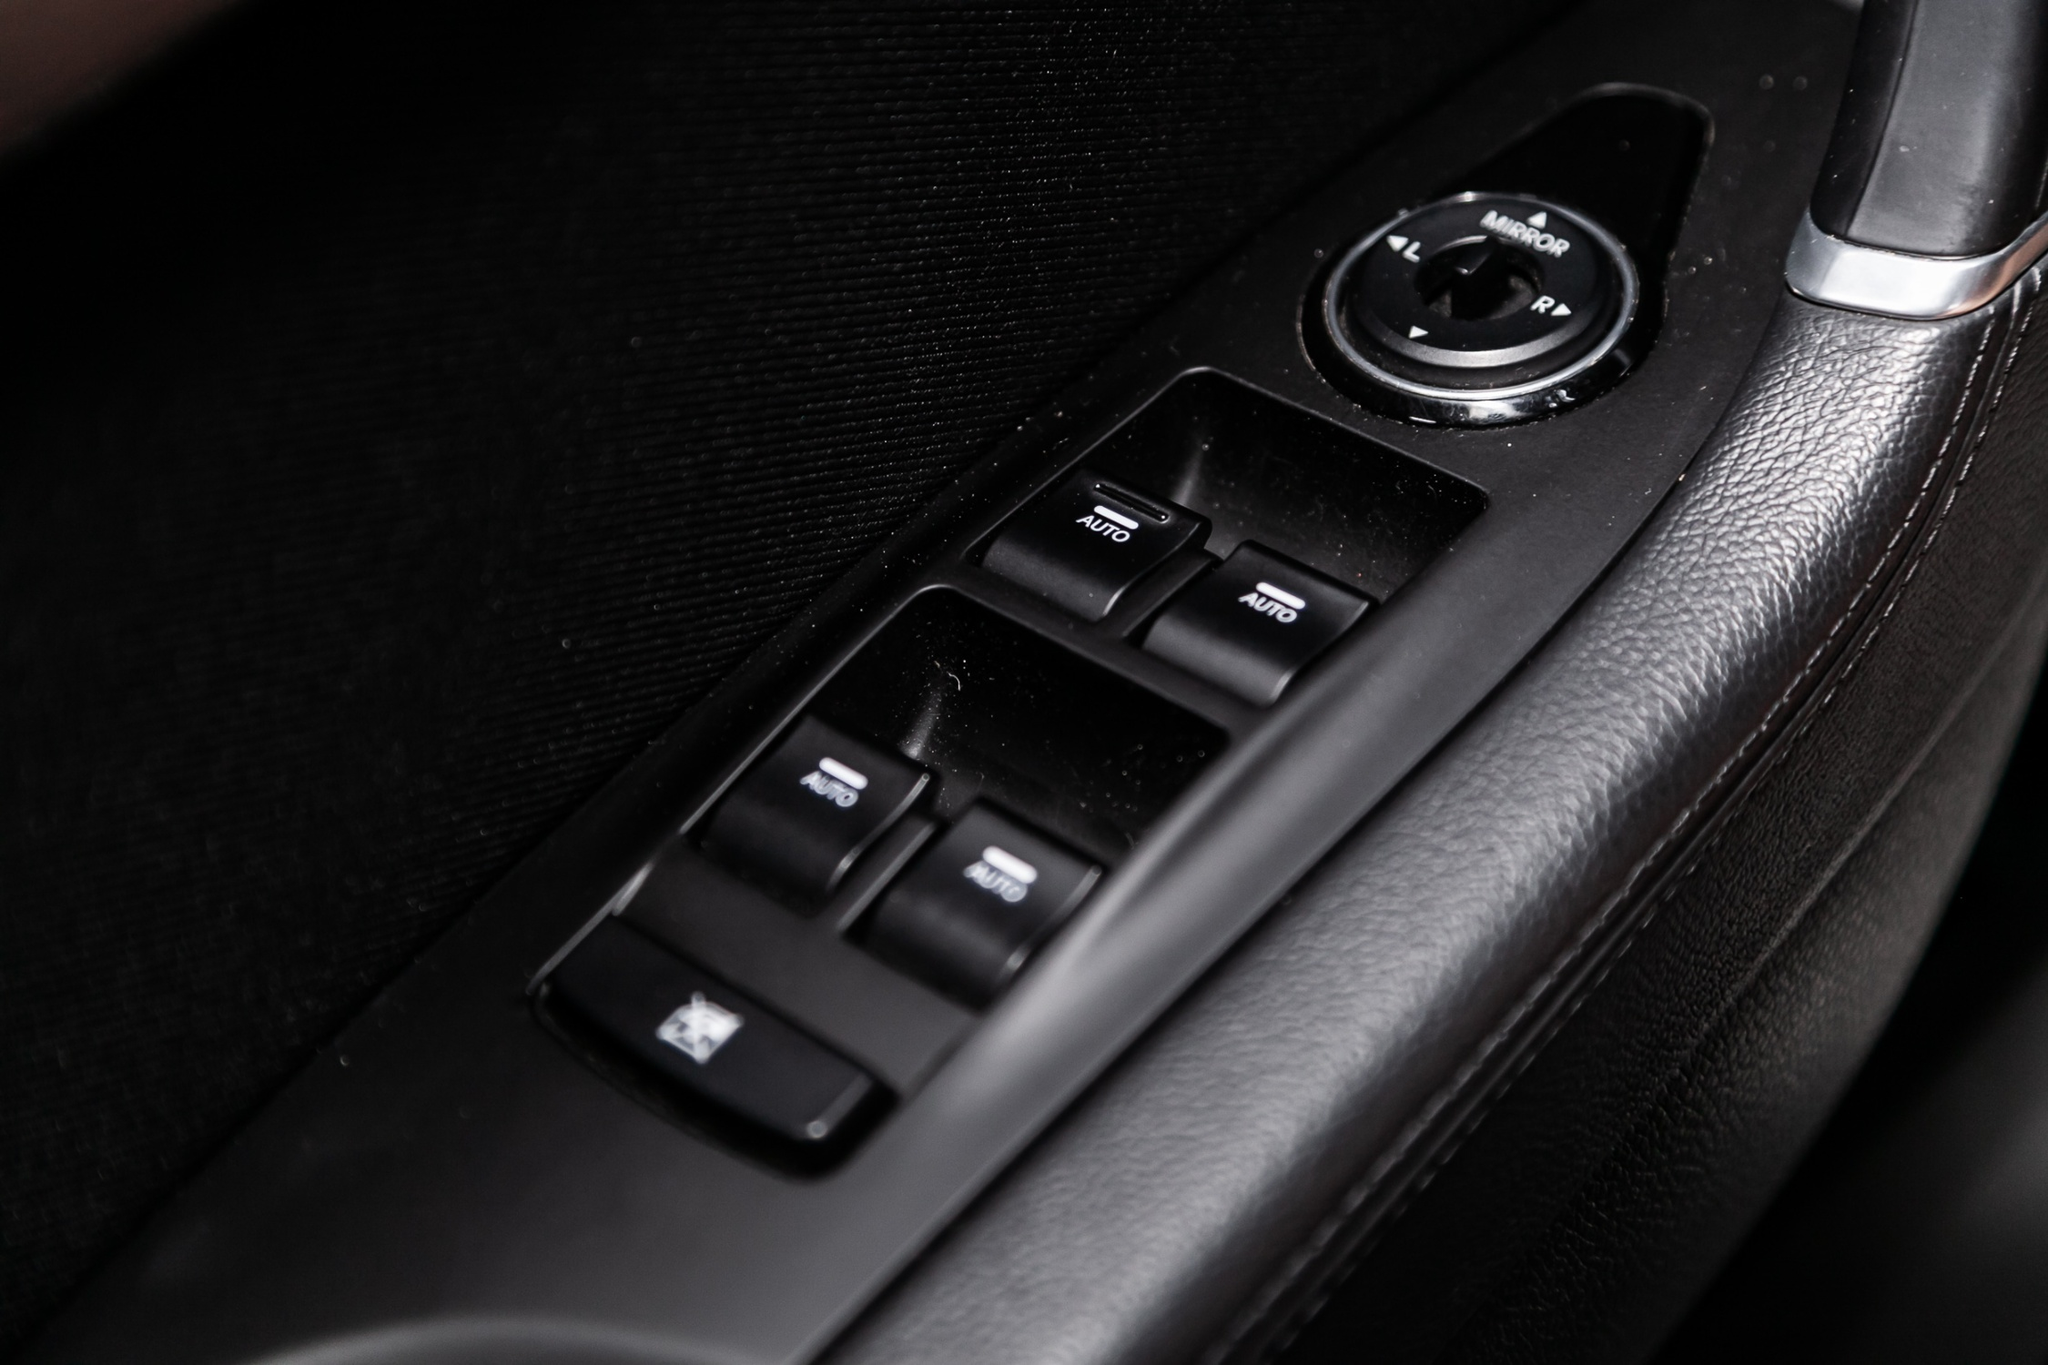If this car were part of a cinematic scene, what role might the driver's side door play? In an action-packed thriller, the driver's side door could play a pivotal role. Imagine a high-speed chase scene where the main character, a skilled undercover agent, has to make a daring escape from enemy pursuers. At a critical moment, the agent deftly uses the controls on the driver's side door panel to execute a series of maneuvers. Pressing the 'AUTO' button, they swiftly close the windows to avoid gunfire. They lock the doors with a quick press, securing themselves inside. As they approach a narrow alley, the agent adjusts the side mirrors using the circular knob to navigate the tight space with precision.

In a tense moment, the 'PWR' button activates reinforced locks, transforming the car into a temporary safe haven as the agent plans their next move. The sleek design and intuitive functionality of the driver's side door controls add an element of high-tech sophistication to this gripping cinematic escape sequence.  Could you provide a shorter description of how the driver's side door controls might be used in an everyday setting? Each morning, Maya drives to her favorite coffee shop. Using the driver's side control panel, she presses the 'AUTO' button to lower the window and place her order at the drive-thru. With another press, she raises the window back up, enjoying the convenience and ease provided by the well-designed buttons for her daily routine. 